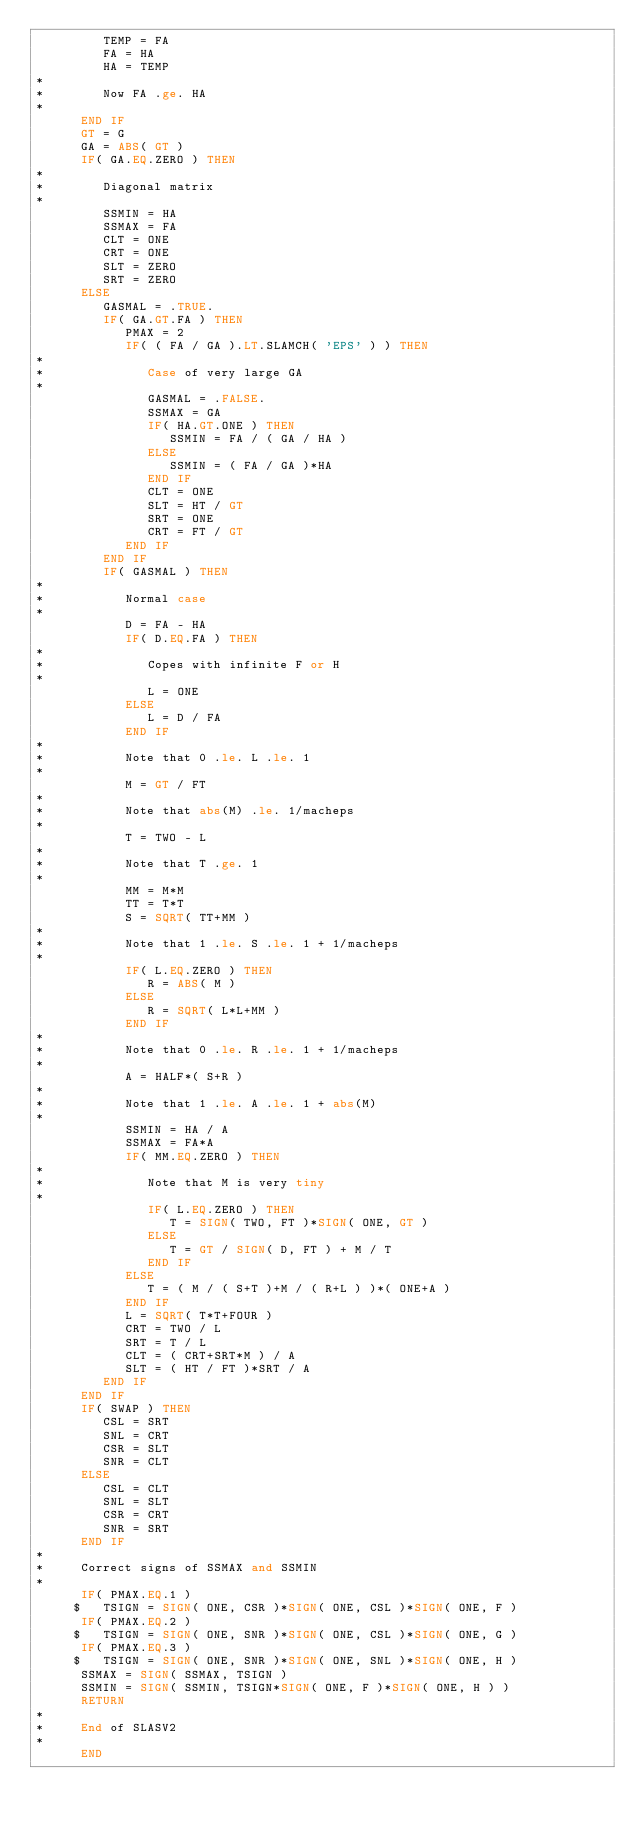<code> <loc_0><loc_0><loc_500><loc_500><_FORTRAN_>         TEMP = FA
         FA = HA
         HA = TEMP
*
*        Now FA .ge. HA
*
      END IF
      GT = G
      GA = ABS( GT )
      IF( GA.EQ.ZERO ) THEN
*
*        Diagonal matrix
*
         SSMIN = HA
         SSMAX = FA
         CLT = ONE
         CRT = ONE
         SLT = ZERO
         SRT = ZERO
      ELSE
         GASMAL = .TRUE.
         IF( GA.GT.FA ) THEN
            PMAX = 2
            IF( ( FA / GA ).LT.SLAMCH( 'EPS' ) ) THEN
*
*              Case of very large GA
*
               GASMAL = .FALSE.
               SSMAX = GA
               IF( HA.GT.ONE ) THEN
                  SSMIN = FA / ( GA / HA )
               ELSE
                  SSMIN = ( FA / GA )*HA
               END IF
               CLT = ONE
               SLT = HT / GT
               SRT = ONE
               CRT = FT / GT
            END IF
         END IF
         IF( GASMAL ) THEN
*
*           Normal case
*
            D = FA - HA
            IF( D.EQ.FA ) THEN
*
*              Copes with infinite F or H
*
               L = ONE
            ELSE
               L = D / FA
            END IF
*
*           Note that 0 .le. L .le. 1
*
            M = GT / FT
*
*           Note that abs(M) .le. 1/macheps
*
            T = TWO - L
*
*           Note that T .ge. 1
*
            MM = M*M
            TT = T*T
            S = SQRT( TT+MM )
*
*           Note that 1 .le. S .le. 1 + 1/macheps
*
            IF( L.EQ.ZERO ) THEN
               R = ABS( M )
            ELSE
               R = SQRT( L*L+MM )
            END IF
*
*           Note that 0 .le. R .le. 1 + 1/macheps
*
            A = HALF*( S+R )
*
*           Note that 1 .le. A .le. 1 + abs(M)
*
            SSMIN = HA / A
            SSMAX = FA*A
            IF( MM.EQ.ZERO ) THEN
*
*              Note that M is very tiny
*
               IF( L.EQ.ZERO ) THEN
                  T = SIGN( TWO, FT )*SIGN( ONE, GT )
               ELSE
                  T = GT / SIGN( D, FT ) + M / T
               END IF
            ELSE
               T = ( M / ( S+T )+M / ( R+L ) )*( ONE+A )
            END IF
            L = SQRT( T*T+FOUR )
            CRT = TWO / L
            SRT = T / L
            CLT = ( CRT+SRT*M ) / A
            SLT = ( HT / FT )*SRT / A
         END IF
      END IF
      IF( SWAP ) THEN
         CSL = SRT
         SNL = CRT
         CSR = SLT
         SNR = CLT
      ELSE
         CSL = CLT
         SNL = SLT
         CSR = CRT
         SNR = SRT
      END IF
*
*     Correct signs of SSMAX and SSMIN
*
      IF( PMAX.EQ.1 )
     $   TSIGN = SIGN( ONE, CSR )*SIGN( ONE, CSL )*SIGN( ONE, F )
      IF( PMAX.EQ.2 )
     $   TSIGN = SIGN( ONE, SNR )*SIGN( ONE, CSL )*SIGN( ONE, G )
      IF( PMAX.EQ.3 )
     $   TSIGN = SIGN( ONE, SNR )*SIGN( ONE, SNL )*SIGN( ONE, H )
      SSMAX = SIGN( SSMAX, TSIGN )
      SSMIN = SIGN( SSMIN, TSIGN*SIGN( ONE, F )*SIGN( ONE, H ) )
      RETURN
*
*     End of SLASV2
*
      END
</code> 